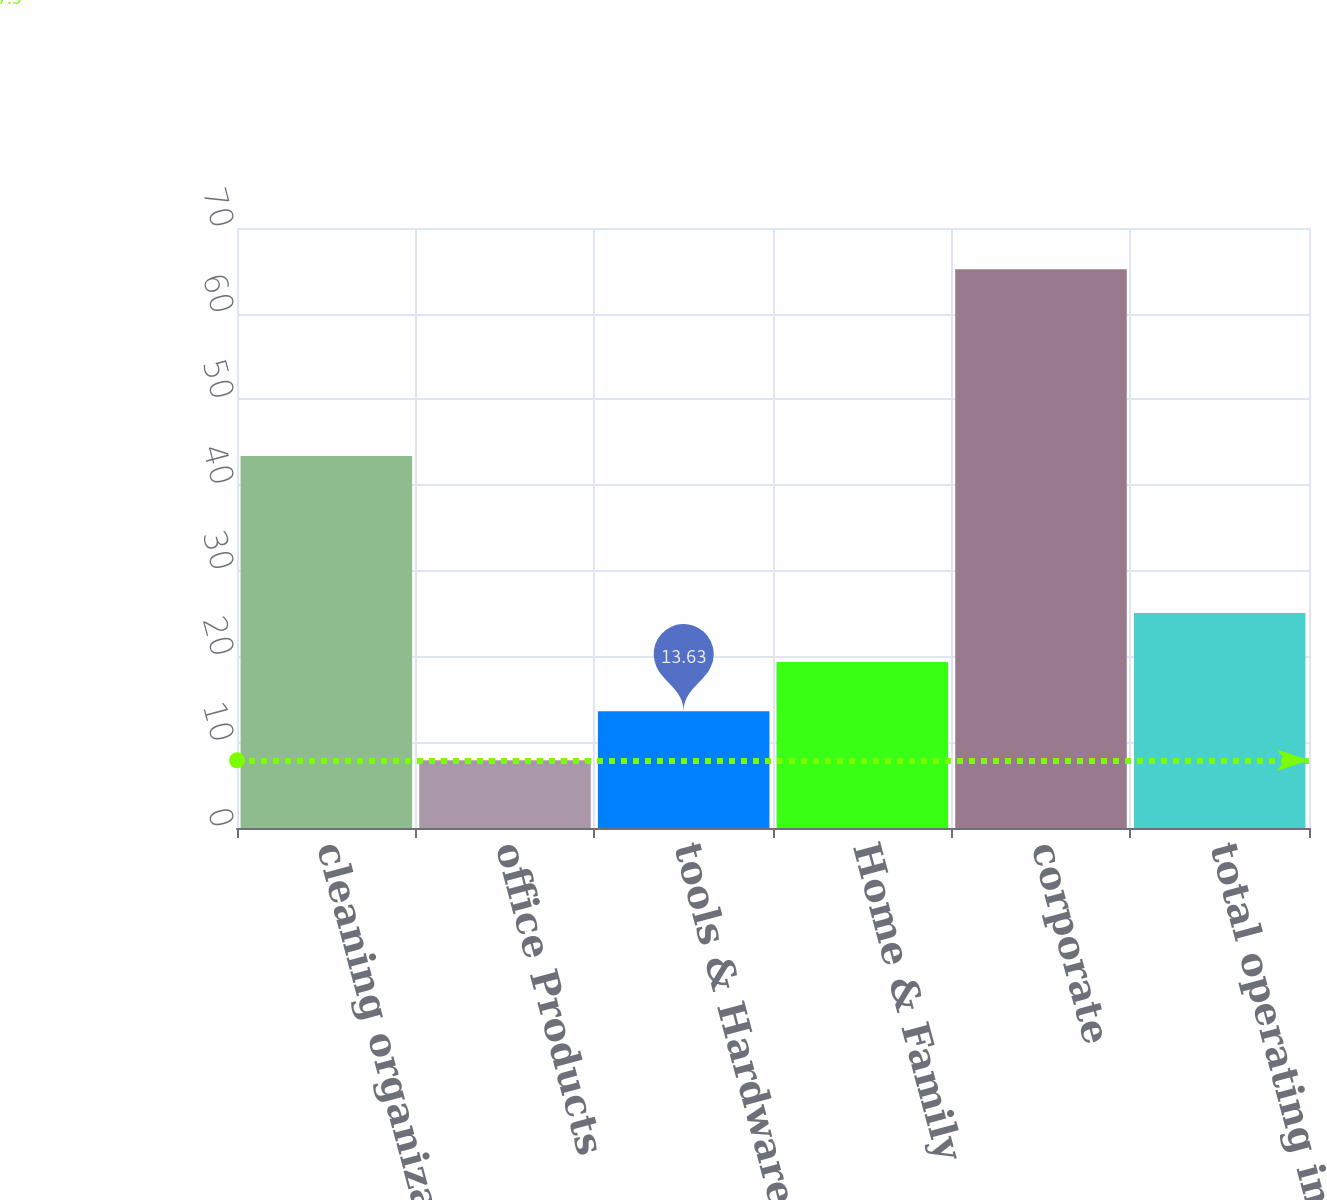Convert chart. <chart><loc_0><loc_0><loc_500><loc_500><bar_chart><fcel>cleaning organization & décor<fcel>office Products<fcel>tools & Hardware<fcel>Home & Family<fcel>corporate<fcel>total operating income<nl><fcel>43.4<fcel>7.9<fcel>13.63<fcel>19.36<fcel>65.2<fcel>25.09<nl></chart> 